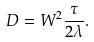<formula> <loc_0><loc_0><loc_500><loc_500>D = W ^ { 2 } \frac { \tau } { 2 \lambda } .</formula> 